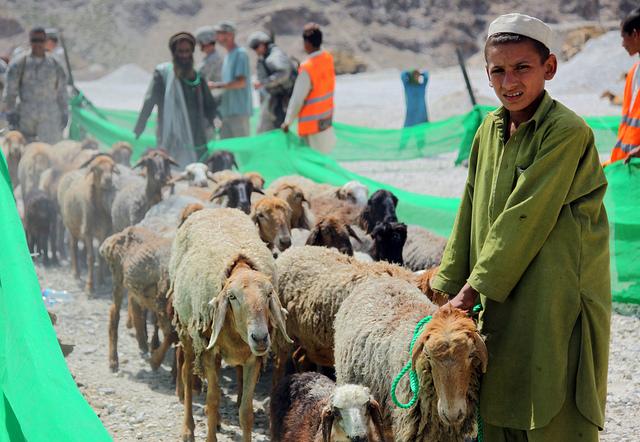What kinds of animals are those?
Quick response, please. Sheep. Is the boy wearing a hat?
Be succinct. Yes. What type of vests are the orange ones?
Short answer required. Safety. 